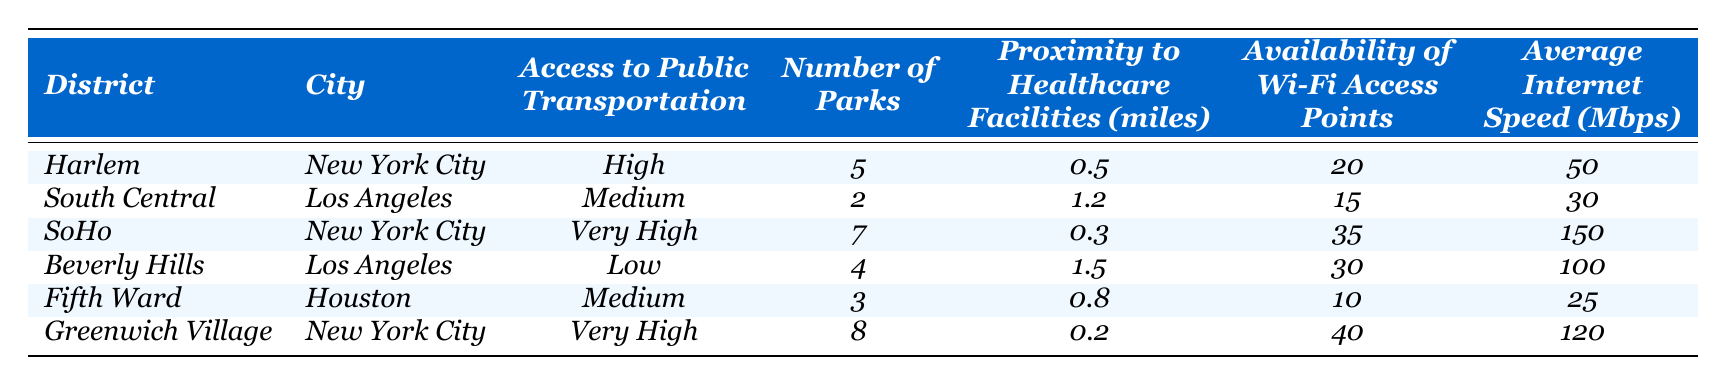What's the access to public transportation in the Greenwich Village district? The table shows that Greenwich Village has "Very High" access to public transportation.
Answer: Very High How many parks are there in South Central? According to the table, South Central has 2 parks listed.
Answer: 2 Which district has the highest average internet speed? Comparing the average internet speeds given for each district, SoHo has the highest speed of 150 Mbps.
Answer: SoHo What is the proximity to healthcare facilities in the Fifth Ward? The table indicates that the proximity to healthcare facilities in the Fifth Ward is 0.8 miles.
Answer: 0.8 miles Is Beverly Hills the district with the lowest access to public transportation? Reviewing the access levels, Beverly Hills has "Low" access, which is lower than others, confirming it is the lowest in this table.
Answer: Yes What is the total number of parks in low-income districts (Harlem, South Central, Fifth Ward, and Beverly Hills)? The number of parks in those districts is 5 (Harlem) + 2 (South Central) + 3 (Fifth Ward) + 4 (Beverly Hills) = 14 parks in total.
Answer: 14 How does the average internet speed compare between low-income districts and high-income districts? The low-income districts’ average internet speeds are: Harlem (50 Mbps), South Central (30 Mbps), Fifth Ward (25 Mbps), and Beverly Hills (100 Mbps); which sums up to 205 Mbps for 4 districts averaging 51.25 Mbps. High-income districts (SoHo and Greenwich Village) have speeds of 150 Mbps and 120 Mbps respectively, averaging 135 Mbps (270 Mbps total for 2 districts). So high-income districts have higher average internet speeds.
Answer: High-income districts have higher speeds Which district has the highest number of Wi-Fi access points? The maximum number of Wi-Fi access points is 40, found in Greenwich Village district according to the table.
Answer: Greenwich Village What is the average proximity to healthcare facilities in high-income districts? The proximity for high-income districts (SoHo at 0.3 miles and Greenwich Village at 0.2 miles) averages to (0.3 + 0.2) / 2 = 0.25 miles.
Answer: 0.25 miles Which district has a medium level of access to public transportation? Checking the public transportation access, both South Central and Fifth Ward are marked as having "Medium" access.
Answer: South Central and Fifth Ward 